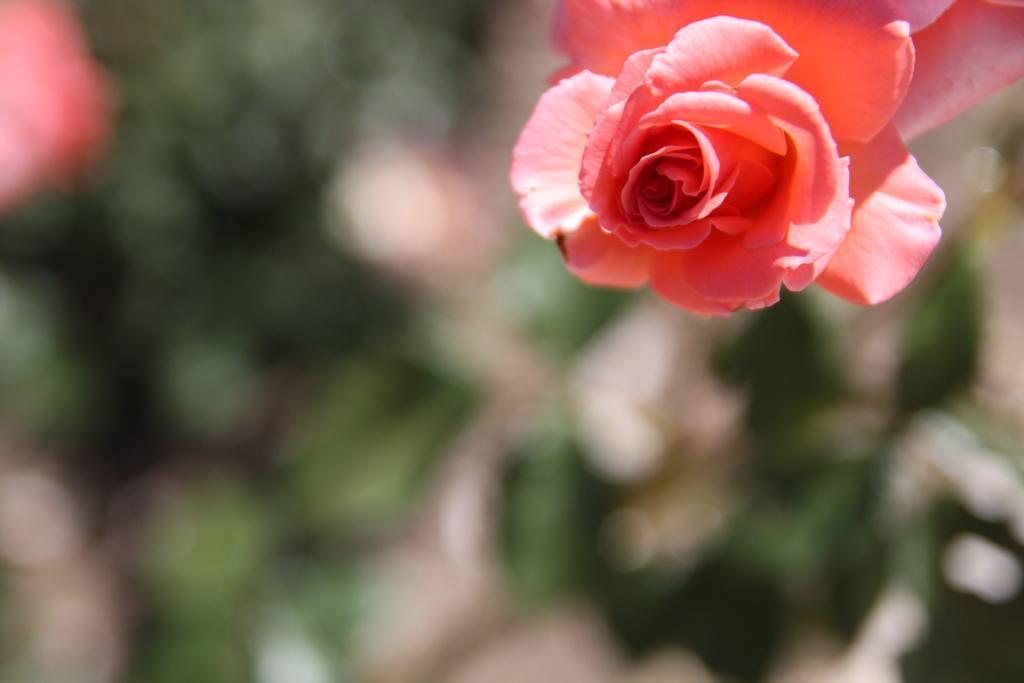Can you describe this image briefly? In this image, we can see a flower and there is a blur background. 